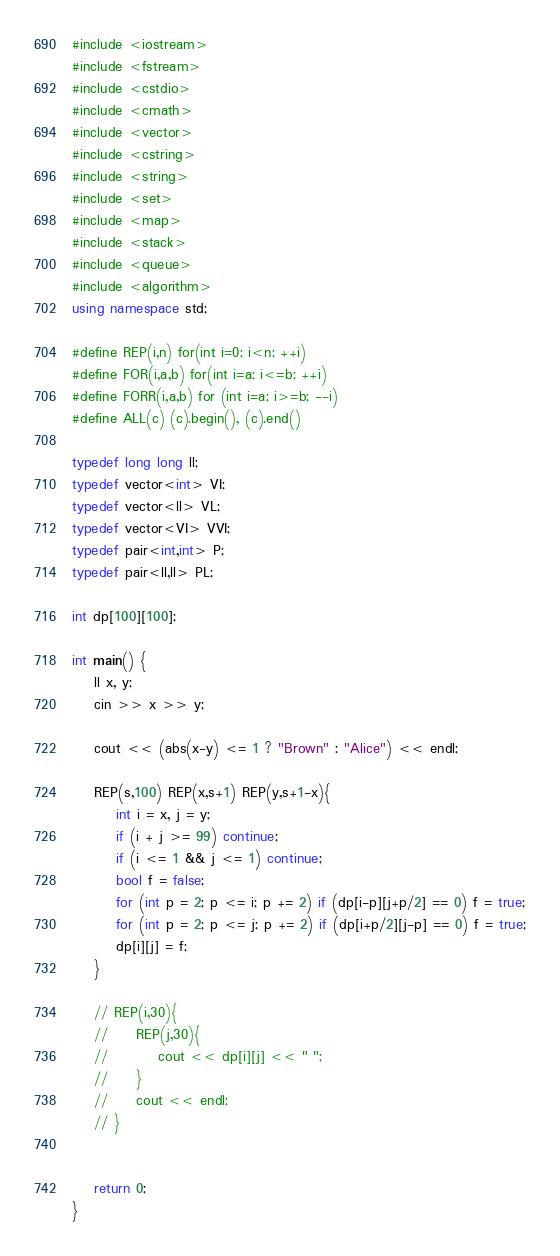<code> <loc_0><loc_0><loc_500><loc_500><_C++_>#include <iostream>
#include <fstream>
#include <cstdio>
#include <cmath>
#include <vector>
#include <cstring>
#include <string>
#include <set>
#include <map>
#include <stack>
#include <queue>
#include <algorithm>
using namespace std;

#define REP(i,n) for(int i=0; i<n; ++i)
#define FOR(i,a,b) for(int i=a; i<=b; ++i)
#define FORR(i,a,b) for (int i=a; i>=b; --i)
#define ALL(c) (c).begin(), (c).end()

typedef long long ll;
typedef vector<int> VI;
typedef vector<ll> VL;
typedef vector<VI> VVI;
typedef pair<int,int> P;
typedef pair<ll,ll> PL;

int dp[100][100];

int main() {
    ll x, y;
    cin >> x >> y;

    cout << (abs(x-y) <= 1 ? "Brown" : "Alice") << endl;

    REP(s,100) REP(x,s+1) REP(y,s+1-x){
        int i = x, j = y;
        if (i + j >= 99) continue;
        if (i <= 1 && j <= 1) continue;
        bool f = false;
        for (int p = 2; p <= i; p += 2) if (dp[i-p][j+p/2] == 0) f = true;
        for (int p = 2; p <= j; p += 2) if (dp[i+p/2][j-p] == 0) f = true;
        dp[i][j] = f;
    }

    // REP(i,30){
    //     REP(j,30){
    //         cout << dp[i][j] << " ";
    //     }
    //     cout << endl;
    // }


    return 0;
}</code> 